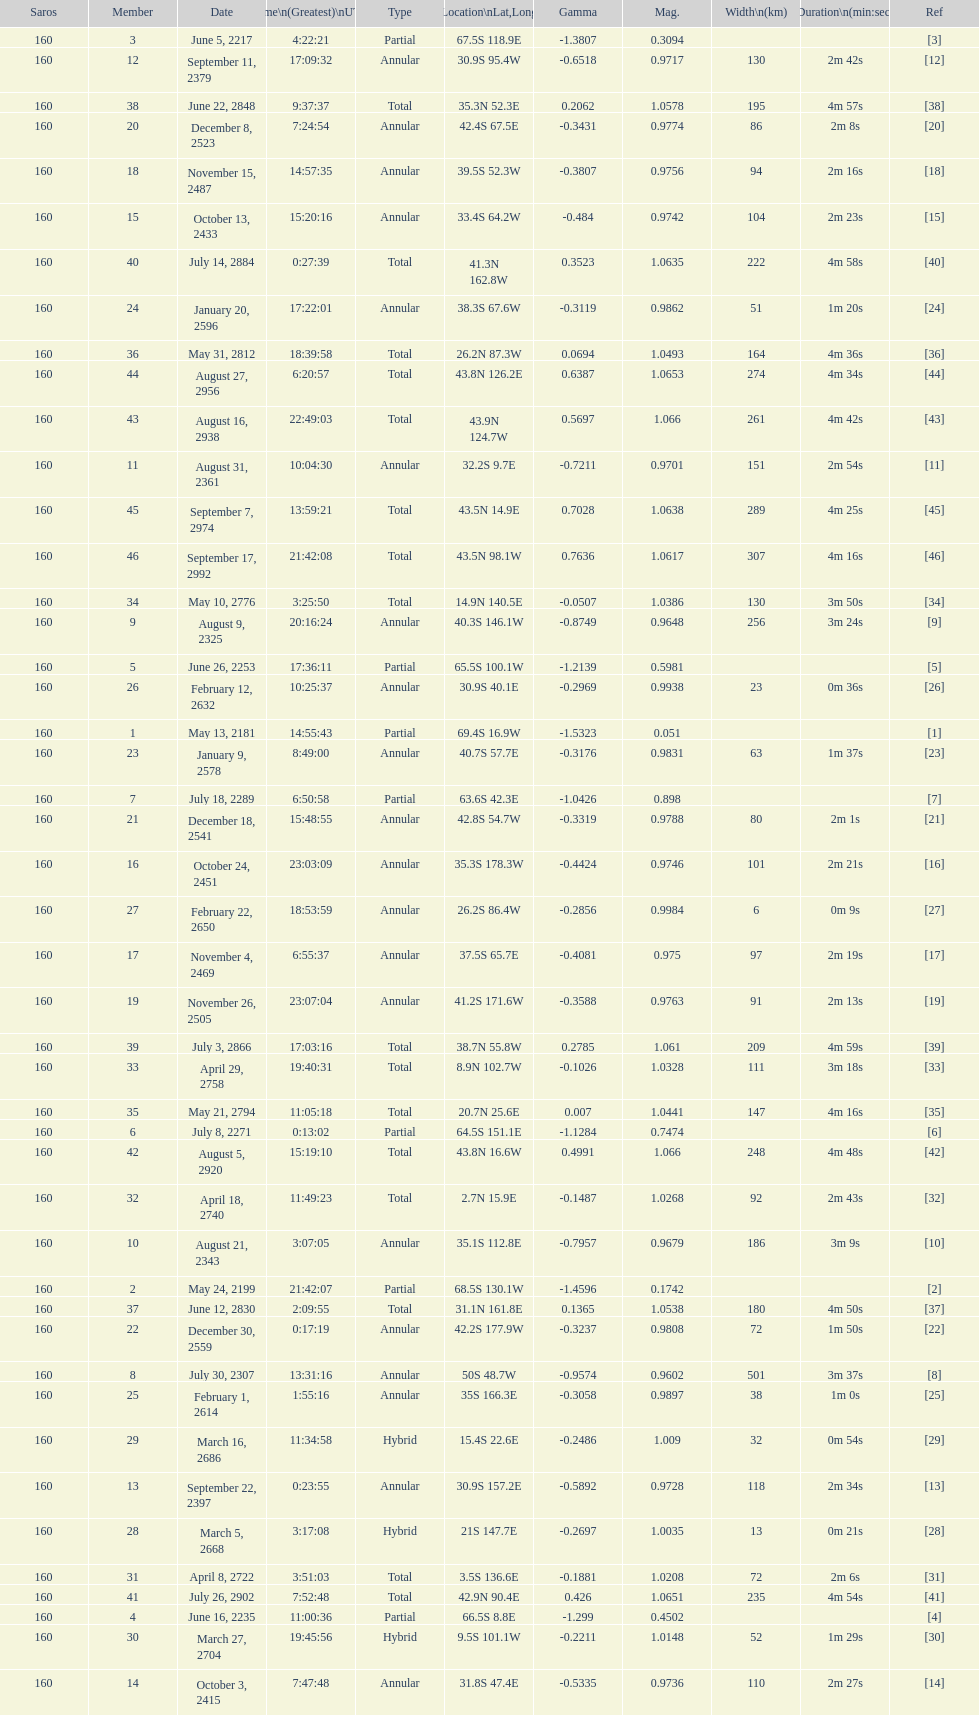How many total events will occur in all? 46. 